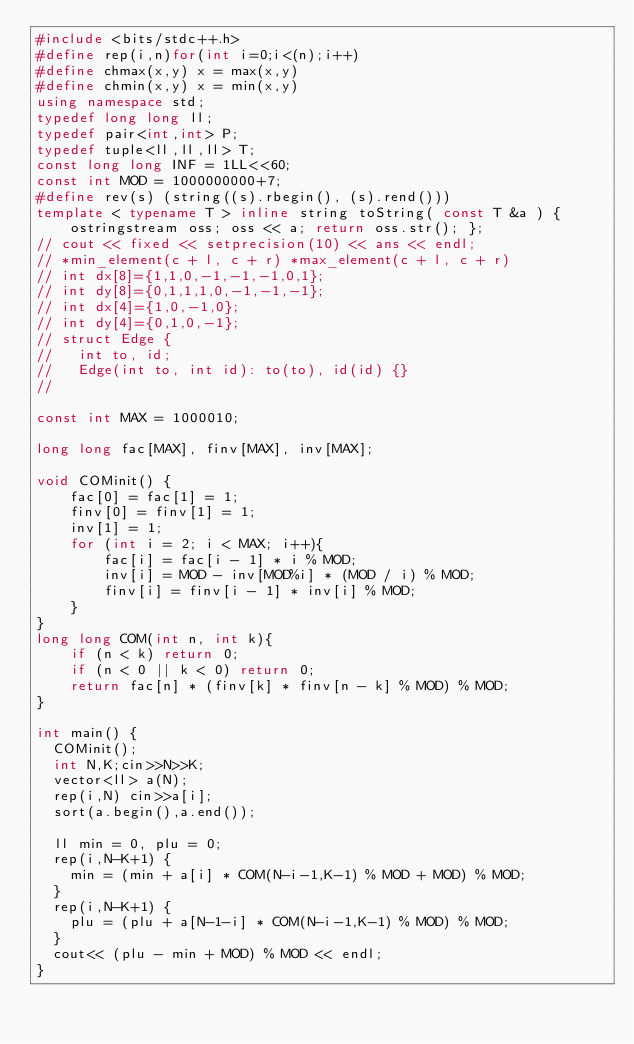<code> <loc_0><loc_0><loc_500><loc_500><_C++_>#include <bits/stdc++.h>
#define rep(i,n)for(int i=0;i<(n);i++)
#define chmax(x,y) x = max(x,y)
#define chmin(x,y) x = min(x,y)
using namespace std;
typedef long long ll;
typedef pair<int,int> P;
typedef tuple<ll,ll,ll> T;
const long long INF = 1LL<<60;
const int MOD = 1000000000+7;
#define rev(s) (string((s).rbegin(), (s).rend()))
template < typename T > inline string toString( const T &a ) { ostringstream oss; oss << a; return oss.str(); };
// cout << fixed << setprecision(10) << ans << endl;
// *min_element(c + l, c + r) *max_element(c + l, c + r)
// int dx[8]={1,1,0,-1,-1,-1,0,1};
// int dy[8]={0,1,1,1,0,-1,-1,-1};
// int dx[4]={1,0,-1,0};
// int dy[4]={0,1,0,-1};
// struct Edge {
//   int to, id;
//   Edge(int to, int id): to(to), id(id) {}
//

const int MAX = 1000010;

long long fac[MAX], finv[MAX], inv[MAX];

void COMinit() {
    fac[0] = fac[1] = 1;
    finv[0] = finv[1] = 1;
    inv[1] = 1;
    for (int i = 2; i < MAX; i++){
        fac[i] = fac[i - 1] * i % MOD;
        inv[i] = MOD - inv[MOD%i] * (MOD / i) % MOD;
        finv[i] = finv[i - 1] * inv[i] % MOD;
    }
}
long long COM(int n, int k){
    if (n < k) return 0;
    if (n < 0 || k < 0) return 0;
    return fac[n] * (finv[k] * finv[n - k] % MOD) % MOD;
}

int main() {
  COMinit();
  int N,K;cin>>N>>K;
  vector<ll> a(N);
  rep(i,N) cin>>a[i];
  sort(a.begin(),a.end());

  ll min = 0, plu = 0;
  rep(i,N-K+1) {
    min = (min + a[i] * COM(N-i-1,K-1) % MOD + MOD) % MOD;
  }
  rep(i,N-K+1) {
    plu = (plu + a[N-1-i] * COM(N-i-1,K-1) % MOD) % MOD;
  }
  cout<< (plu - min + MOD) % MOD << endl; 
}
</code> 